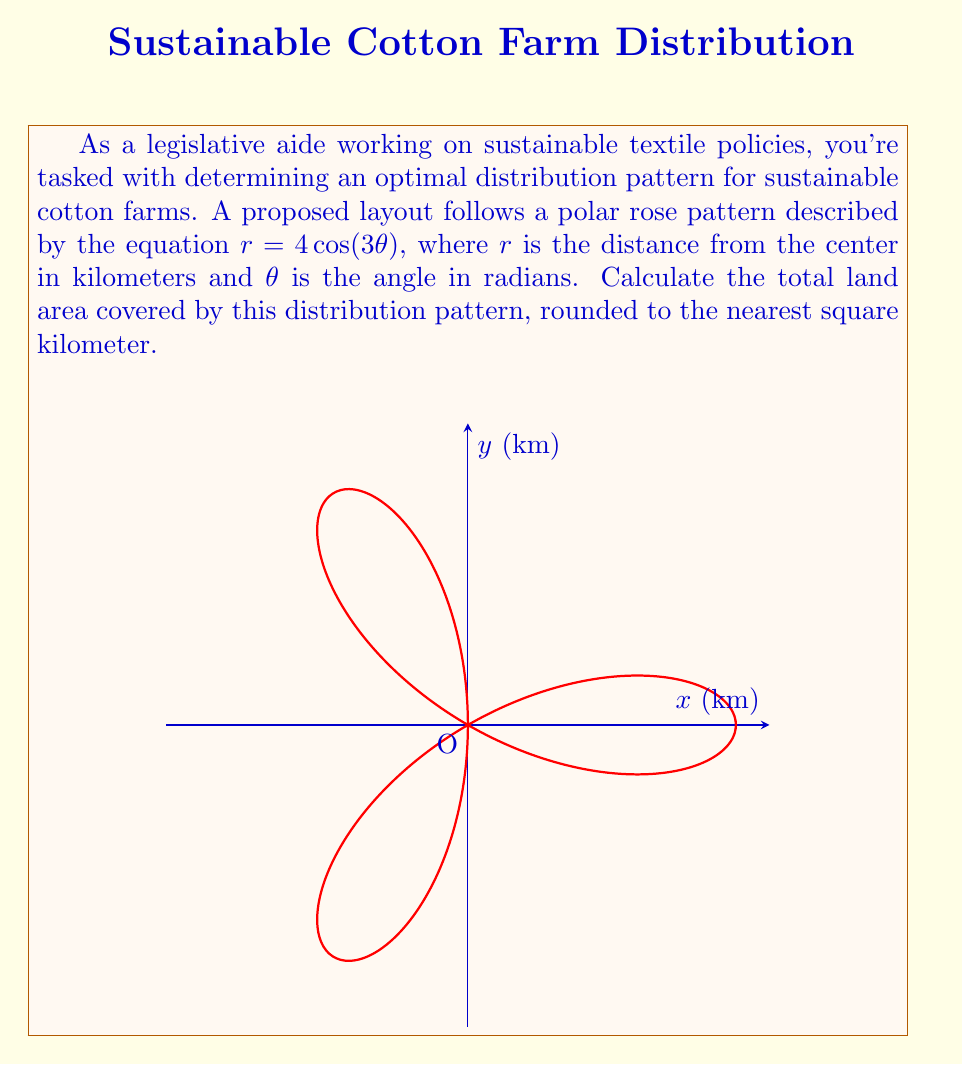Teach me how to tackle this problem. To solve this problem, we'll follow these steps:

1) The area of a polar rose is given by the formula:

   $$A = \frac{n}{2} \int_0^{2\pi/n} r^2 d\theta$$

   where $n$ is the number of petals.

2) In our case, $r = 4\cos(3\theta)$ and $n = 3$ (since the cosine function completes 3 full cycles in $2\pi$).

3) Substituting into the formula:

   $$A = \frac{3}{2} \int_0^{2\pi/3} (4\cos(3\theta))^2 d\theta$$

4) Simplify the integrand:

   $$A = 24 \int_0^{2\pi/3} \cos^2(3\theta) d\theta$$

5) Use the trigonometric identity $\cos^2 x = \frac{1 + \cos(2x)}{2}$:

   $$A = 24 \int_0^{2\pi/3} \frac{1 + \cos(6\theta)}{2} d\theta$$

6) Simplify:

   $$A = 12 \int_0^{2\pi/3} (1 + \cos(6\theta)) d\theta$$

7) Integrate:

   $$A = 12 [\theta + \frac{1}{6}\sin(6\theta)]_0^{2\pi/3}$$

8) Evaluate the limits:

   $$A = 12 [(\frac{2\pi}{3} + 0) - (0 + 0)] = 8\pi$$

9) The result is in square kilometers. Rounding to the nearest integer:

   $$A \approx 25 \text{ km}^2$$
Answer: 25 km² 